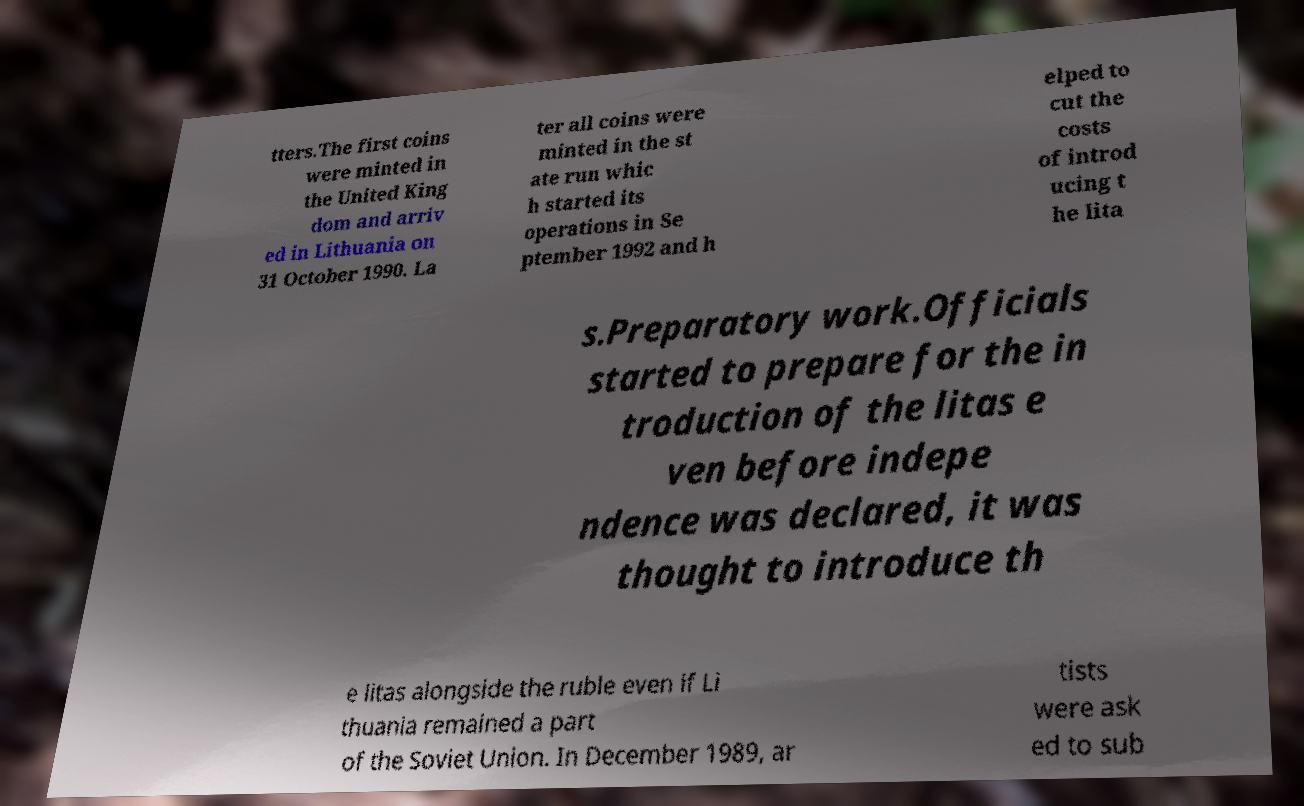Please identify and transcribe the text found in this image. tters.The first coins were minted in the United King dom and arriv ed in Lithuania on 31 October 1990. La ter all coins were minted in the st ate run whic h started its operations in Se ptember 1992 and h elped to cut the costs of introd ucing t he lita s.Preparatory work.Officials started to prepare for the in troduction of the litas e ven before indepe ndence was declared, it was thought to introduce th e litas alongside the ruble even if Li thuania remained a part of the Soviet Union. In December 1989, ar tists were ask ed to sub 